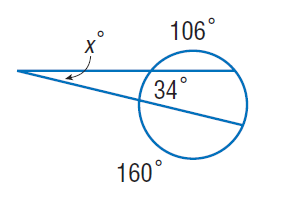Answer the mathemtical geometry problem and directly provide the correct option letter.
Question: Find x. Assume that any segment that appears to be tangent is tangent.
Choices: A: 13 B: 34 C: 106 D: 160 A 